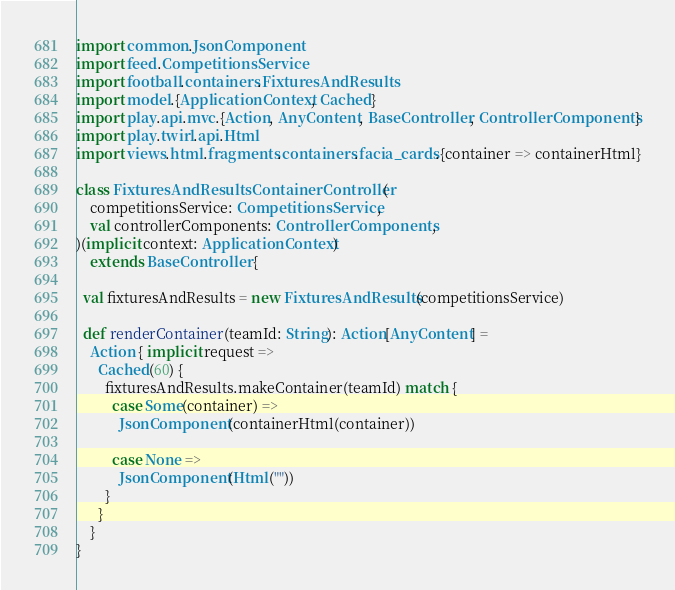Convert code to text. <code><loc_0><loc_0><loc_500><loc_500><_Scala_>import common.JsonComponent
import feed.CompetitionsService
import football.containers.FixturesAndResults
import model.{ApplicationContext, Cached}
import play.api.mvc.{Action, AnyContent, BaseController, ControllerComponents}
import play.twirl.api.Html
import views.html.fragments.containers.facia_cards.{container => containerHtml}

class FixturesAndResultsContainerController(
    competitionsService: CompetitionsService,
    val controllerComponents: ControllerComponents,
)(implicit context: ApplicationContext)
    extends BaseController {

  val fixturesAndResults = new FixturesAndResults(competitionsService)

  def renderContainer(teamId: String): Action[AnyContent] =
    Action { implicit request =>
      Cached(60) {
        fixturesAndResults.makeContainer(teamId) match {
          case Some(container) =>
            JsonComponent(containerHtml(container))

          case None =>
            JsonComponent(Html(""))
        }
      }
    }
}
</code> 